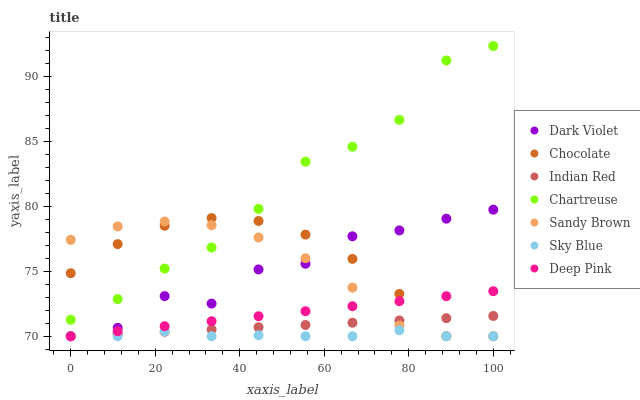Does Sky Blue have the minimum area under the curve?
Answer yes or no. Yes. Does Chartreuse have the maximum area under the curve?
Answer yes or no. Yes. Does Dark Violet have the minimum area under the curve?
Answer yes or no. No. Does Dark Violet have the maximum area under the curve?
Answer yes or no. No. Is Deep Pink the smoothest?
Answer yes or no. Yes. Is Dark Violet the roughest?
Answer yes or no. Yes. Is Chocolate the smoothest?
Answer yes or no. No. Is Chocolate the roughest?
Answer yes or no. No. Does Deep Pink have the lowest value?
Answer yes or no. Yes. Does Chartreuse have the lowest value?
Answer yes or no. No. Does Chartreuse have the highest value?
Answer yes or no. Yes. Does Dark Violet have the highest value?
Answer yes or no. No. Is Deep Pink less than Chartreuse?
Answer yes or no. Yes. Is Chartreuse greater than Deep Pink?
Answer yes or no. Yes. Does Indian Red intersect Chocolate?
Answer yes or no. Yes. Is Indian Red less than Chocolate?
Answer yes or no. No. Is Indian Red greater than Chocolate?
Answer yes or no. No. Does Deep Pink intersect Chartreuse?
Answer yes or no. No. 